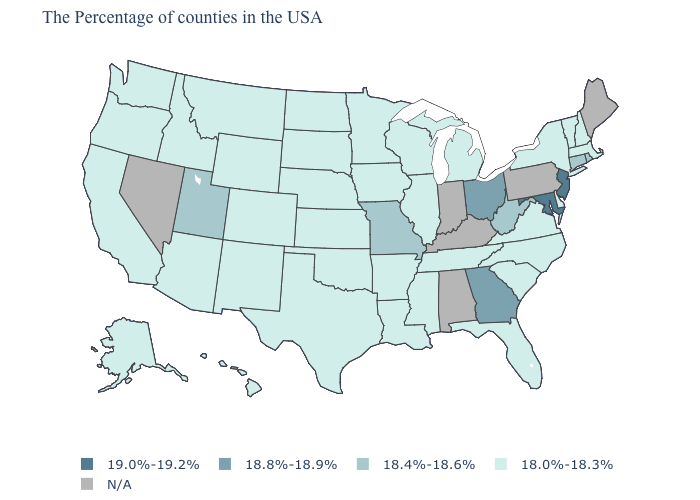Name the states that have a value in the range N/A?
Quick response, please. Maine, Pennsylvania, Kentucky, Indiana, Alabama, Nevada. Name the states that have a value in the range 18.0%-18.3%?
Quick response, please. Massachusetts, New Hampshire, Vermont, New York, Delaware, Virginia, North Carolina, South Carolina, Florida, Michigan, Tennessee, Wisconsin, Illinois, Mississippi, Louisiana, Arkansas, Minnesota, Iowa, Kansas, Nebraska, Oklahoma, Texas, South Dakota, North Dakota, Wyoming, Colorado, New Mexico, Montana, Arizona, Idaho, California, Washington, Oregon, Alaska, Hawaii. Among the states that border West Virginia , does Ohio have the lowest value?
Give a very brief answer. No. Among the states that border Maryland , does Virginia have the highest value?
Keep it brief. No. Does West Virginia have the highest value in the USA?
Be succinct. No. What is the highest value in states that border Mississippi?
Concise answer only. 18.0%-18.3%. What is the value of New Hampshire?
Give a very brief answer. 18.0%-18.3%. What is the value of Arkansas?
Give a very brief answer. 18.0%-18.3%. What is the lowest value in the USA?
Keep it brief. 18.0%-18.3%. Among the states that border Illinois , which have the highest value?
Give a very brief answer. Missouri. Does Ohio have the lowest value in the USA?
Concise answer only. No. Does New Hampshire have the lowest value in the USA?
Concise answer only. Yes. What is the lowest value in the USA?
Keep it brief. 18.0%-18.3%. Name the states that have a value in the range 18.0%-18.3%?
Write a very short answer. Massachusetts, New Hampshire, Vermont, New York, Delaware, Virginia, North Carolina, South Carolina, Florida, Michigan, Tennessee, Wisconsin, Illinois, Mississippi, Louisiana, Arkansas, Minnesota, Iowa, Kansas, Nebraska, Oklahoma, Texas, South Dakota, North Dakota, Wyoming, Colorado, New Mexico, Montana, Arizona, Idaho, California, Washington, Oregon, Alaska, Hawaii. Does the first symbol in the legend represent the smallest category?
Concise answer only. No. 